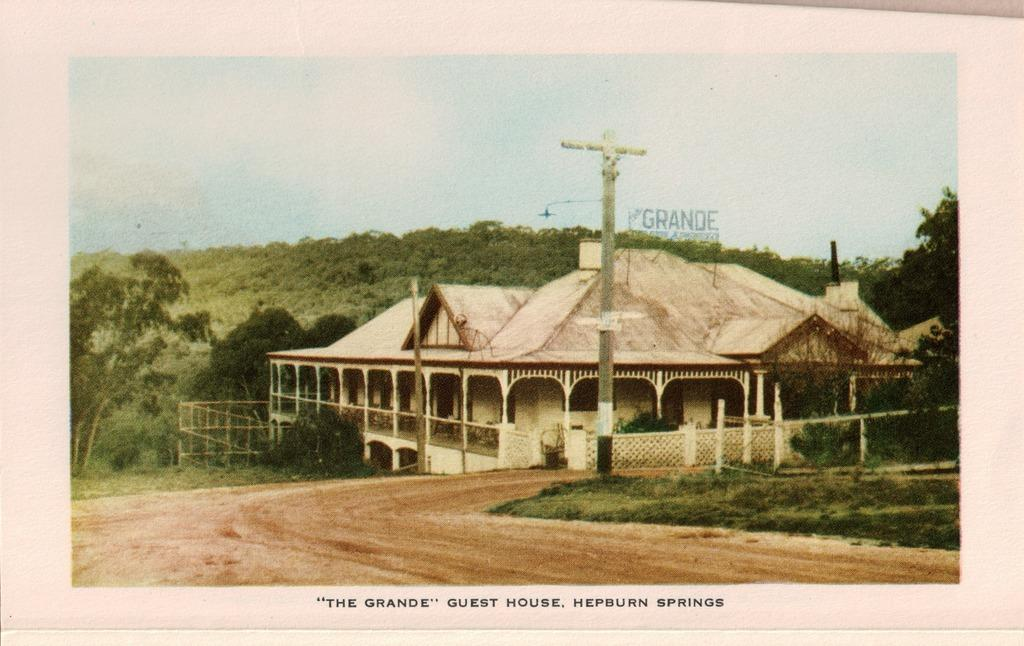What type of structure is visible in the image? There is a house in the image. What is located on the ground near the house? There is a pole on the ground in the image. What can be seen on the ground in the image besides the pole? There is grass on the ground in the image. What is the main feature of the landscape in the image? There is a road in the image. What can be seen in the background of the image? There are trees and the sky visible in the background of the image. Where is the partner standing in the image? There is no partner present in the image. What type of mine can be seen in the image? There is no mine present in the image. 